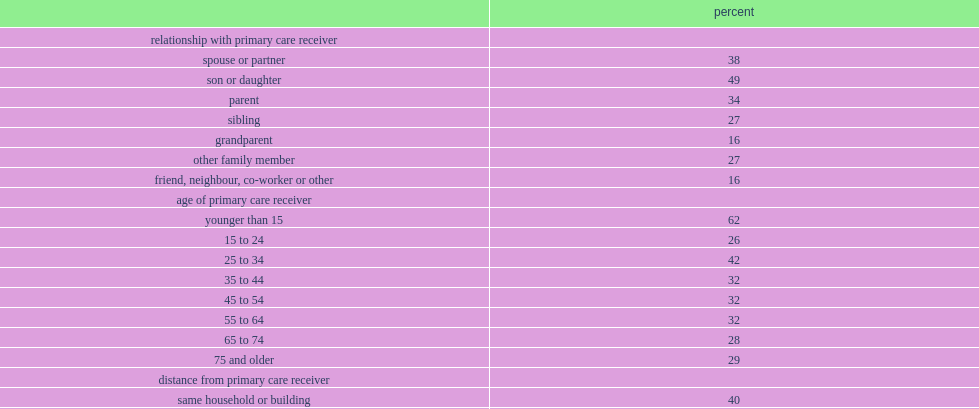What was the percent of caregivers who lived in the same household as their care recipient said that their support needs were not met? 40.0. What was the percent of those who lived between 10 and 29 minutes away by car? 25.0. What was the percent of caregivers who visited their primary care receiver less than once a month reported that they would have liked to have received more support? 24.0. What was the figure among caregivers who said they visited their primary care receiver daily? 29.0. 